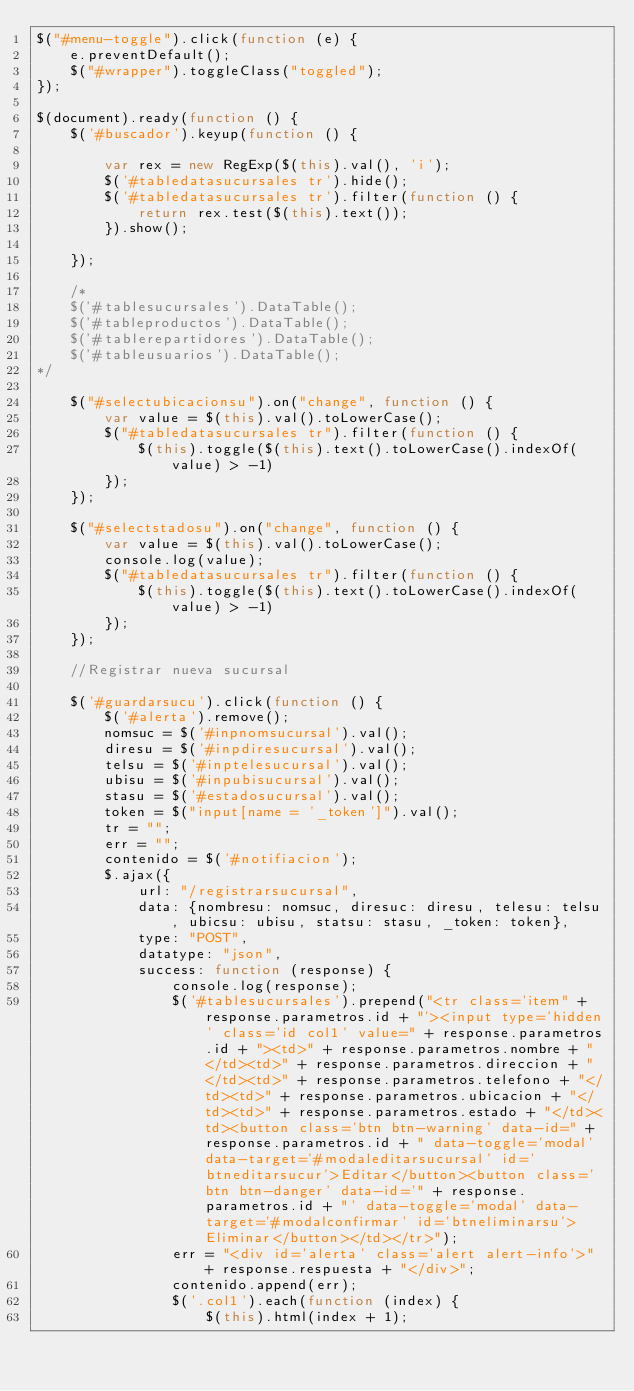<code> <loc_0><loc_0><loc_500><loc_500><_JavaScript_>$("#menu-toggle").click(function (e) {
    e.preventDefault();
    $("#wrapper").toggleClass("toggled");
});

$(document).ready(function () {
    $('#buscador').keyup(function () {

        var rex = new RegExp($(this).val(), 'i');
        $('#tabledatasucursales tr').hide();
        $('#tabledatasucursales tr').filter(function () {
            return rex.test($(this).text());
        }).show();

    });

    /*
    $('#tablesucursales').DataTable();
    $('#tableproductos').DataTable();
    $('#tablerepartidores').DataTable();
    $('#tableusuarios').DataTable();
*/

    $("#selectubicacionsu").on("change", function () {
        var value = $(this).val().toLowerCase();
        $("#tabledatasucursales tr").filter(function () {
            $(this).toggle($(this).text().toLowerCase().indexOf(value) > -1)
        });
    });

    $("#selectstadosu").on("change", function () {
        var value = $(this).val().toLowerCase();
        console.log(value);
        $("#tabledatasucursales tr").filter(function () {
            $(this).toggle($(this).text().toLowerCase().indexOf(value) > -1)
        });
    });

    //Registrar nueva sucursal

    $('#guardarsucu').click(function () {
        $('#alerta').remove();
        nomsuc = $('#inpnomsucursal').val();
        diresu = $('#inpdiresucursal').val();
        telsu = $('#inptelesucursal').val();
        ubisu = $('#inpubisucursal').val();
        stasu = $('#estadosucursal').val();
        token = $("input[name = '_token']").val();
        tr = "";
        err = "";
        contenido = $('#notifiacion');
        $.ajax({
            url: "/registrarsucursal",
            data: {nombresu: nomsuc, diresuc: diresu, telesu: telsu, ubicsu: ubisu, statsu: stasu, _token: token},
            type: "POST",
            datatype: "json",
            success: function (response) {
                console.log(response);
                $('#tablesucursales').prepend("<tr class='item" + response.parametros.id + "'><input type='hidden' class='id col1' value=" + response.parametros.id + "><td>" + response.parametros.nombre + "</td><td>" + response.parametros.direccion + "</td><td>" + response.parametros.telefono + "</td><td>" + response.parametros.ubicacion + "</td><td>" + response.parametros.estado + "</td><td><button class='btn btn-warning' data-id=" + response.parametros.id + " data-toggle='modal' data-target='#modaleditarsucursal' id='btneditarsucur'>Editar</button><button class='btn btn-danger' data-id='" + response.parametros.id + "' data-toggle='modal' data-target='#modalconfirmar' id='btneliminarsu'>Eliminar</button></td></tr>");
                err = "<div id='alerta' class='alert alert-info'>" + response.respuesta + "</div>";
                contenido.append(err);
                $('.col1').each(function (index) {
                    $(this).html(index + 1);</code> 